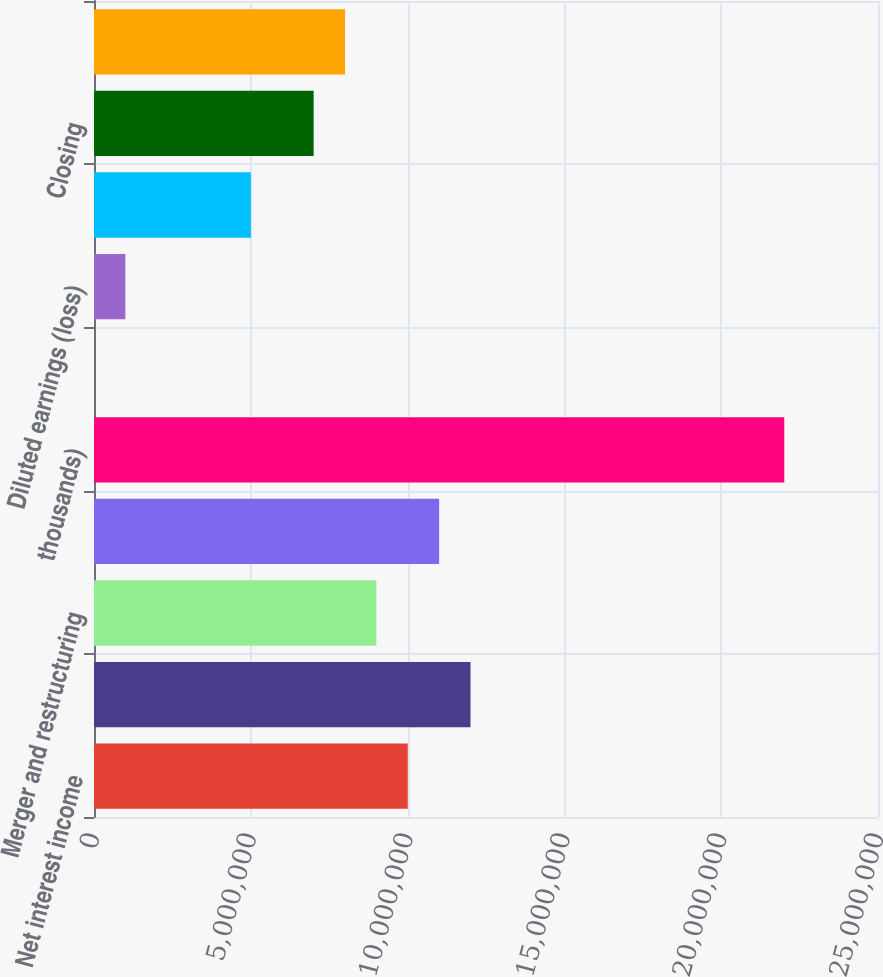Convert chart to OTSL. <chart><loc_0><loc_0><loc_500><loc_500><bar_chart><fcel>Net interest income<fcel>Noninterest income<fcel>Merger and restructuring<fcel>All other noninterest expense<fcel>thousands)<fcel>Earnings (loss)<fcel>Diluted earnings (loss)<fcel>Tangible book value (3)<fcel>Closing<fcel>High closing<nl><fcel>1.00053e+07<fcel>1.20063e+07<fcel>9.00473e+06<fcel>1.10058e+07<fcel>2.20116e+07<fcel>0.28<fcel>1.00053e+06<fcel>5.00263e+06<fcel>7.00368e+06<fcel>8.0042e+06<nl></chart> 